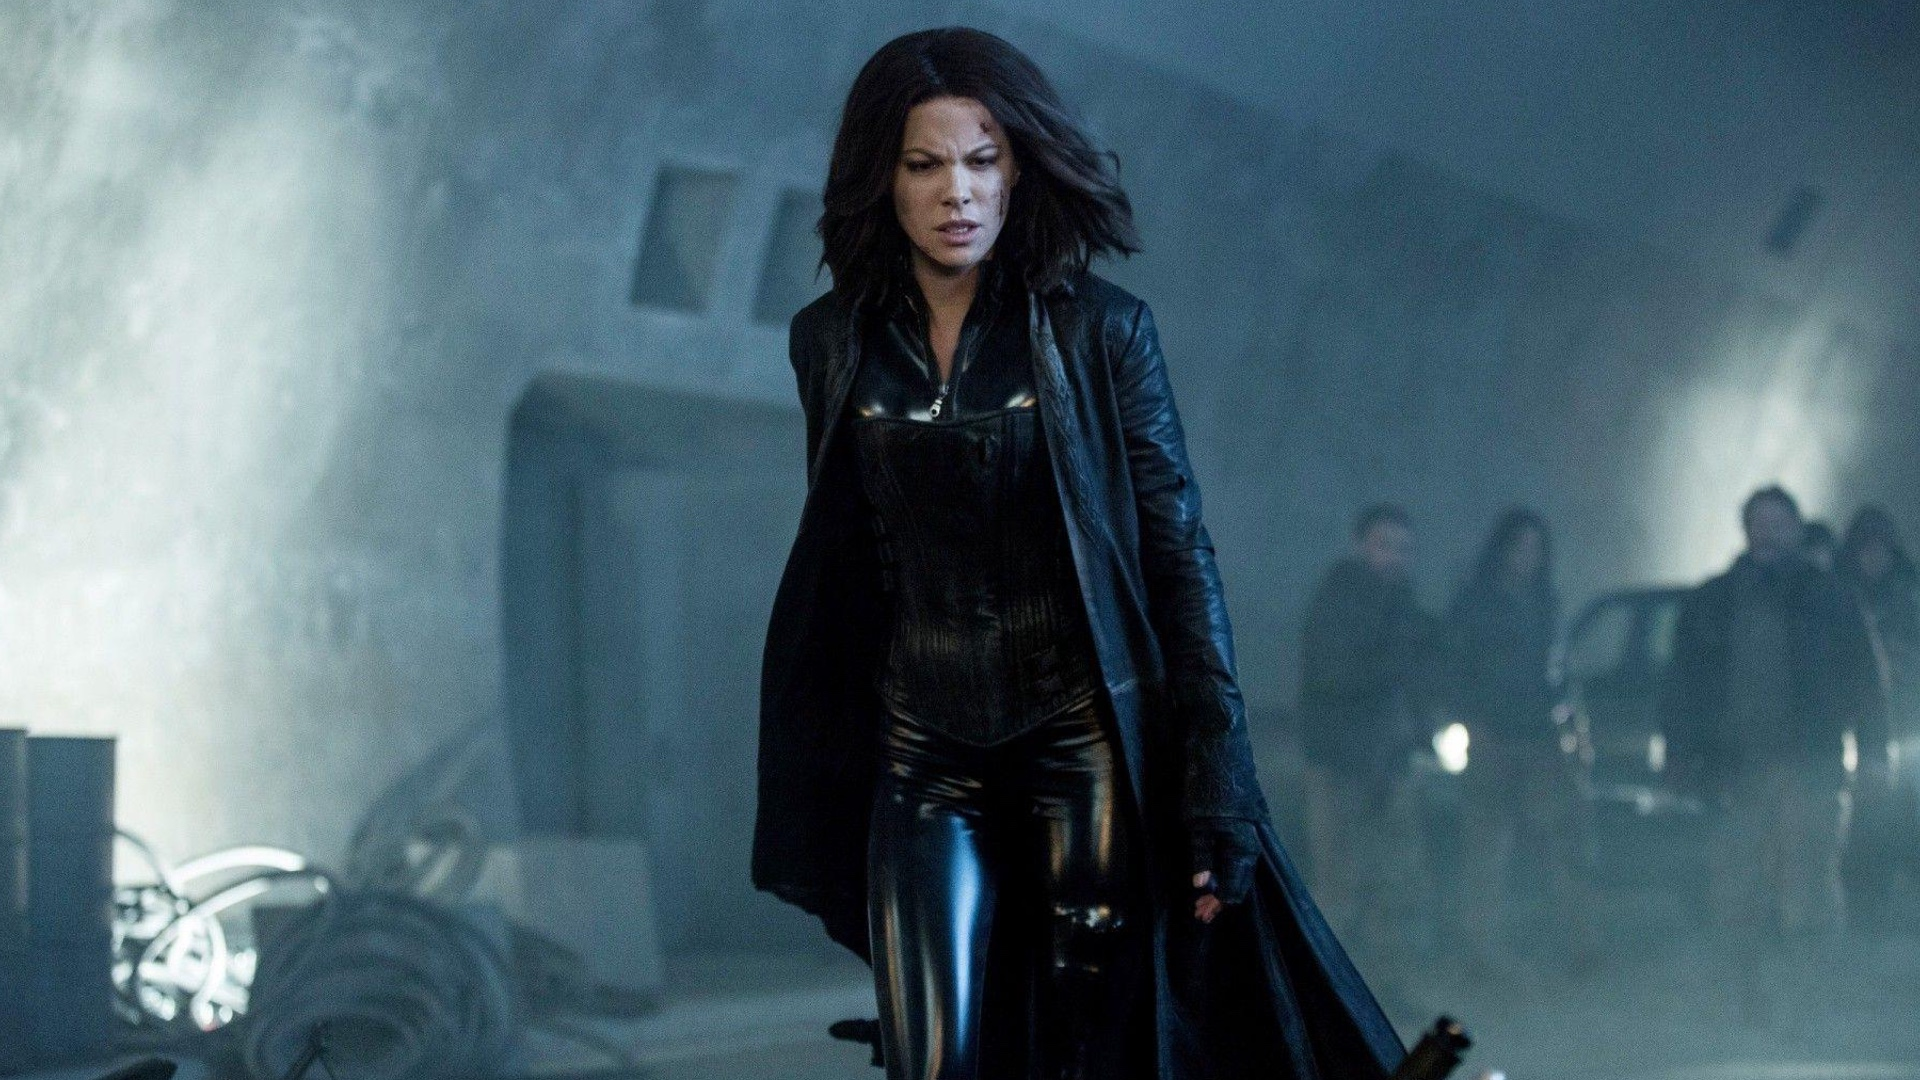What could be the reason behind the fog in the scene? The fog in the scene might be a deliberate choice to enhance the mysterious and eerie atmosphere. It could symbolize the unclear and perilous path that lies ahead for Selene, as she navigates through the shadows of her adversaries. Additionally, the fog can be seen as a visual representation of the hidden truths and secrets within the Underworld universe, hinting at unseen dangers and the complexity of the ongoing conflict. If this image was part of a dream sequence, what would it signify? If this image was part of a dream sequence, it could signify an internal struggle within Selene. The fog could represent the murky depths of her subconscious, where unresolved conflicts and fears reside. Her determined stride might symbolize her relentless pursuit of clarity and resolution despite the overwhelming uncertainties she faces. The industrial backdrop could reflect a cold and unfeeling world, underscoring the isolation and detachment she feels. This dream sequence could be a metaphor for her journey through personal and external battles, highlighting her resilience and unwavering spirit in the face of adversity. 